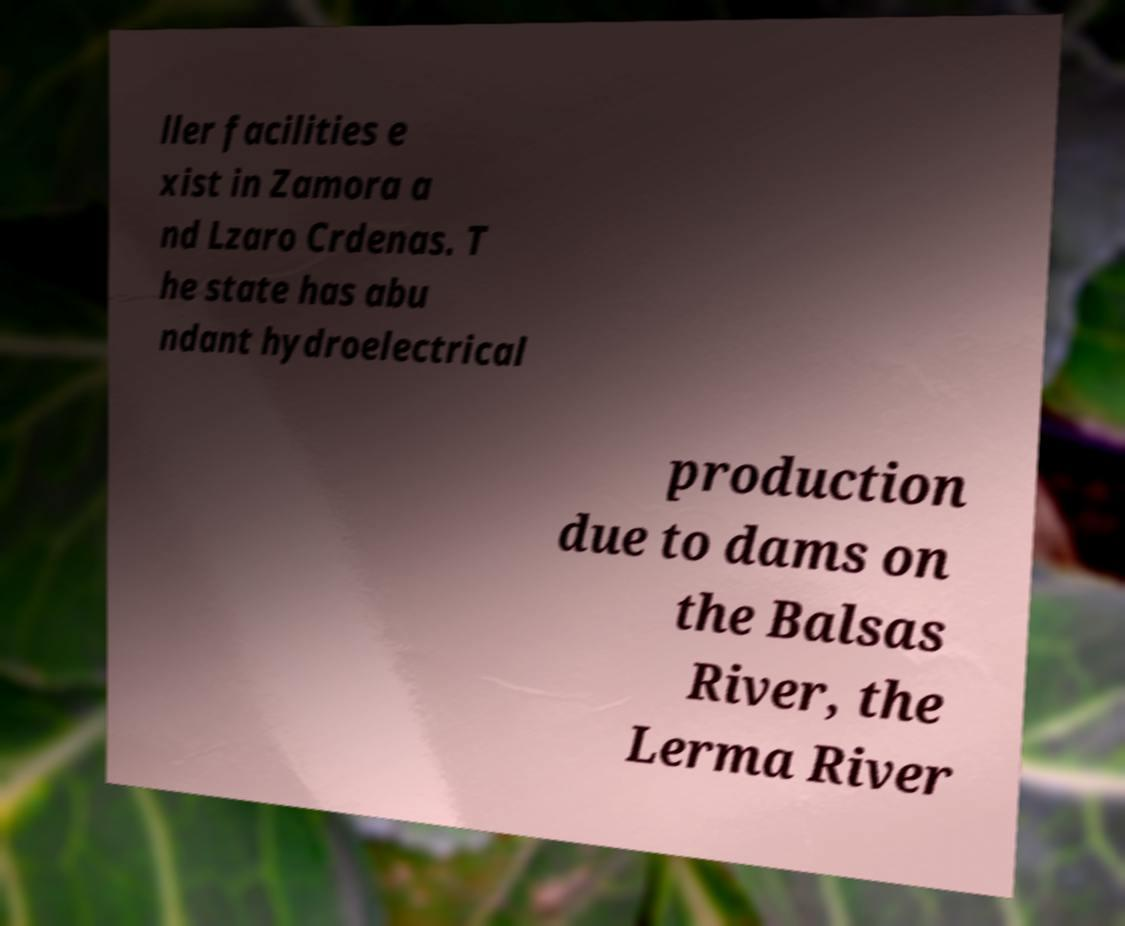Can you accurately transcribe the text from the provided image for me? ller facilities e xist in Zamora a nd Lzaro Crdenas. T he state has abu ndant hydroelectrical production due to dams on the Balsas River, the Lerma River 